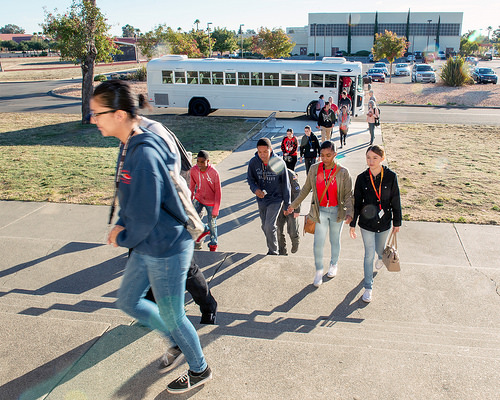<image>
Is the bus next to the person? Yes. The bus is positioned adjacent to the person, located nearby in the same general area. 